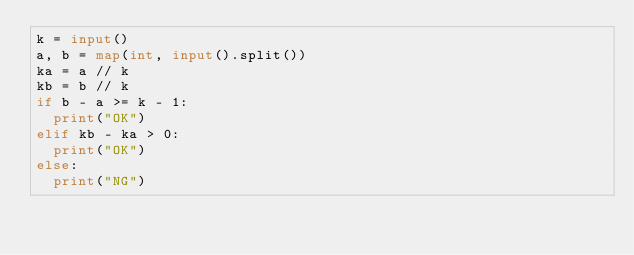Convert code to text. <code><loc_0><loc_0><loc_500><loc_500><_Python_>k = input()
a, b = map(int, input().split())
ka = a // k
kb = b // k
if b - a >= k - 1:
  print("OK")
elif kb - ka > 0:
  print("OK")
else:
  print("NG")</code> 